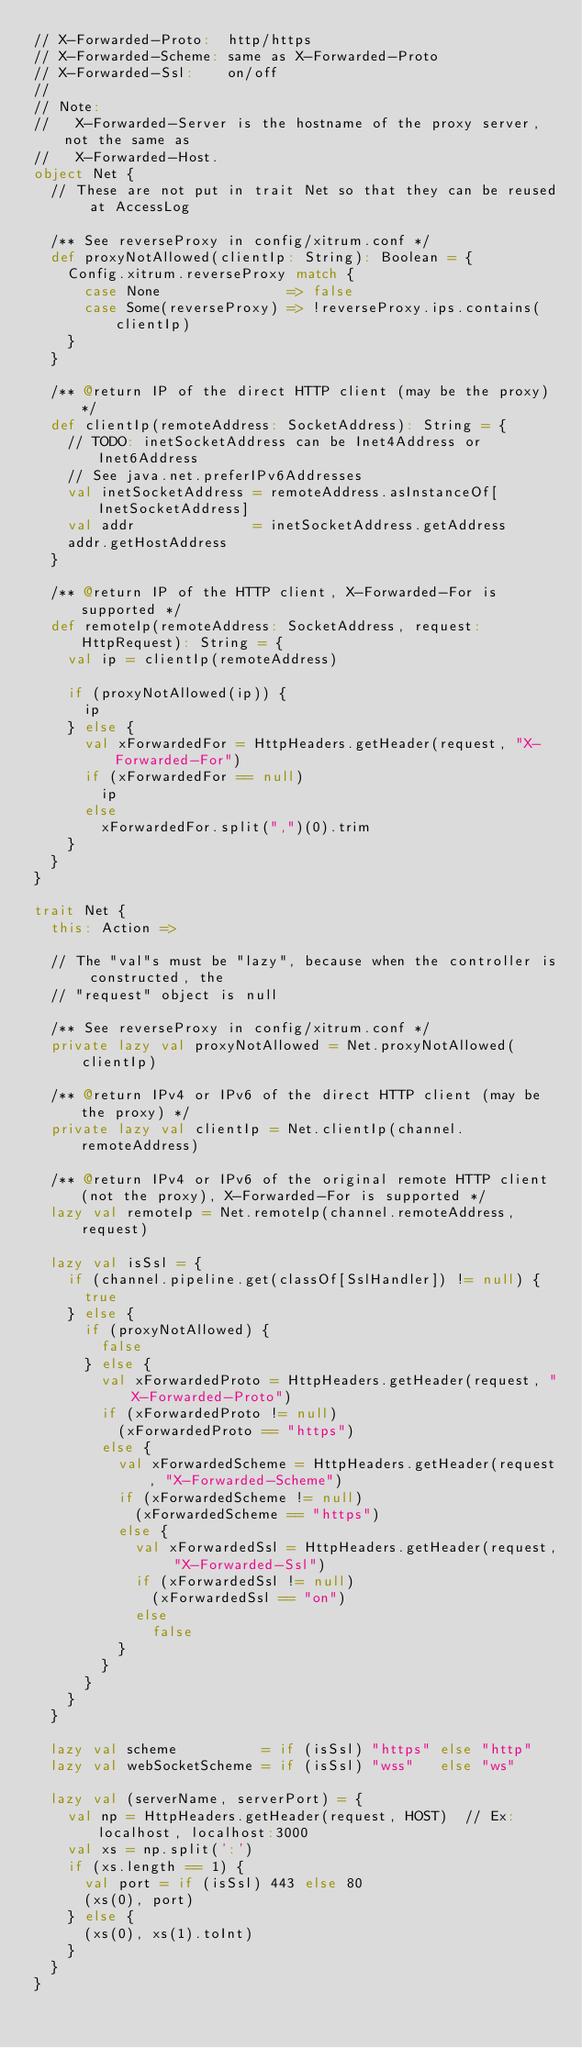Convert code to text. <code><loc_0><loc_0><loc_500><loc_500><_Scala_>// X-Forwarded-Proto:  http/https
// X-Forwarded-Scheme: same as X-Forwarded-Proto
// X-Forwarded-Ssl:    on/off
//
// Note:
//   X-Forwarded-Server is the hostname of the proxy server, not the same as
//   X-Forwarded-Host.
object Net {
  // These are not put in trait Net so that they can be reused at AccessLog

  /** See reverseProxy in config/xitrum.conf */
  def proxyNotAllowed(clientIp: String): Boolean = {
    Config.xitrum.reverseProxy match {
      case None               => false
      case Some(reverseProxy) => !reverseProxy.ips.contains(clientIp)
    }
  }

  /** @return IP of the direct HTTP client (may be the proxy) */
  def clientIp(remoteAddress: SocketAddress): String = {
    // TODO: inetSocketAddress can be Inet4Address or Inet6Address
    // See java.net.preferIPv6Addresses
    val inetSocketAddress = remoteAddress.asInstanceOf[InetSocketAddress]
    val addr              = inetSocketAddress.getAddress
    addr.getHostAddress
  }

  /** @return IP of the HTTP client, X-Forwarded-For is supported */
  def remoteIp(remoteAddress: SocketAddress, request: HttpRequest): String = {
    val ip = clientIp(remoteAddress)

    if (proxyNotAllowed(ip)) {
      ip
    } else {
      val xForwardedFor = HttpHeaders.getHeader(request, "X-Forwarded-For")
      if (xForwardedFor == null)
        ip
      else
        xForwardedFor.split(",")(0).trim
    }
  }
}

trait Net {
  this: Action =>

  // The "val"s must be "lazy", because when the controller is constructed, the
  // "request" object is null

  /** See reverseProxy in config/xitrum.conf */
  private lazy val proxyNotAllowed = Net.proxyNotAllowed(clientIp)

  /** @return IPv4 or IPv6 of the direct HTTP client (may be the proxy) */
  private lazy val clientIp = Net.clientIp(channel.remoteAddress)

  /** @return IPv4 or IPv6 of the original remote HTTP client (not the proxy), X-Forwarded-For is supported */
  lazy val remoteIp = Net.remoteIp(channel.remoteAddress, request)

  lazy val isSsl = {
    if (channel.pipeline.get(classOf[SslHandler]) != null) {
      true
    } else {
      if (proxyNotAllowed) {
        false
      } else {
        val xForwardedProto = HttpHeaders.getHeader(request, "X-Forwarded-Proto")
        if (xForwardedProto != null)
          (xForwardedProto == "https")
        else {
          val xForwardedScheme = HttpHeaders.getHeader(request, "X-Forwarded-Scheme")
          if (xForwardedScheme != null)
            (xForwardedScheme == "https")
          else {
            val xForwardedSsl = HttpHeaders.getHeader(request, "X-Forwarded-Ssl")
            if (xForwardedSsl != null)
              (xForwardedSsl == "on")
            else
              false
          }
        }
      }
    }
  }

  lazy val scheme          = if (isSsl) "https" else "http"
  lazy val webSocketScheme = if (isSsl) "wss"   else "ws"

  lazy val (serverName, serverPort) = {
    val np = HttpHeaders.getHeader(request, HOST)  // Ex: localhost, localhost:3000
    val xs = np.split(':')
    if (xs.length == 1) {
      val port = if (isSsl) 443 else 80
      (xs(0), port)
    } else {
      (xs(0), xs(1).toInt)
    }
  }
}
</code> 